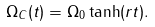<formula> <loc_0><loc_0><loc_500><loc_500>\Omega _ { C } ( t ) = \Omega _ { 0 } \tanh ( r t ) .</formula> 